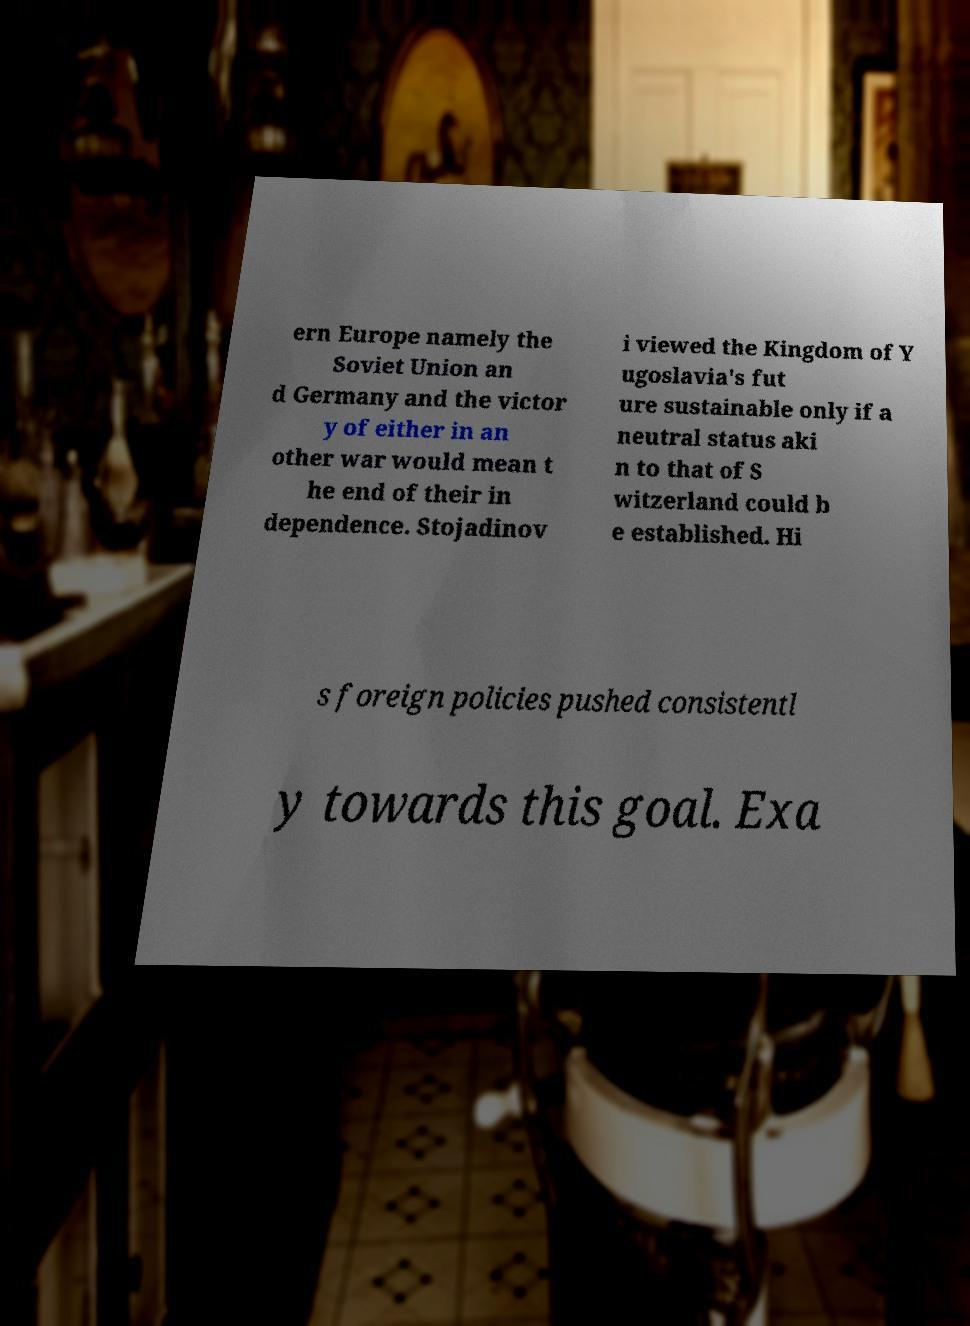I need the written content from this picture converted into text. Can you do that? ern Europe namely the Soviet Union an d Germany and the victor y of either in an other war would mean t he end of their in dependence. Stojadinov i viewed the Kingdom of Y ugoslavia's fut ure sustainable only if a neutral status aki n to that of S witzerland could b e established. Hi s foreign policies pushed consistentl y towards this goal. Exa 